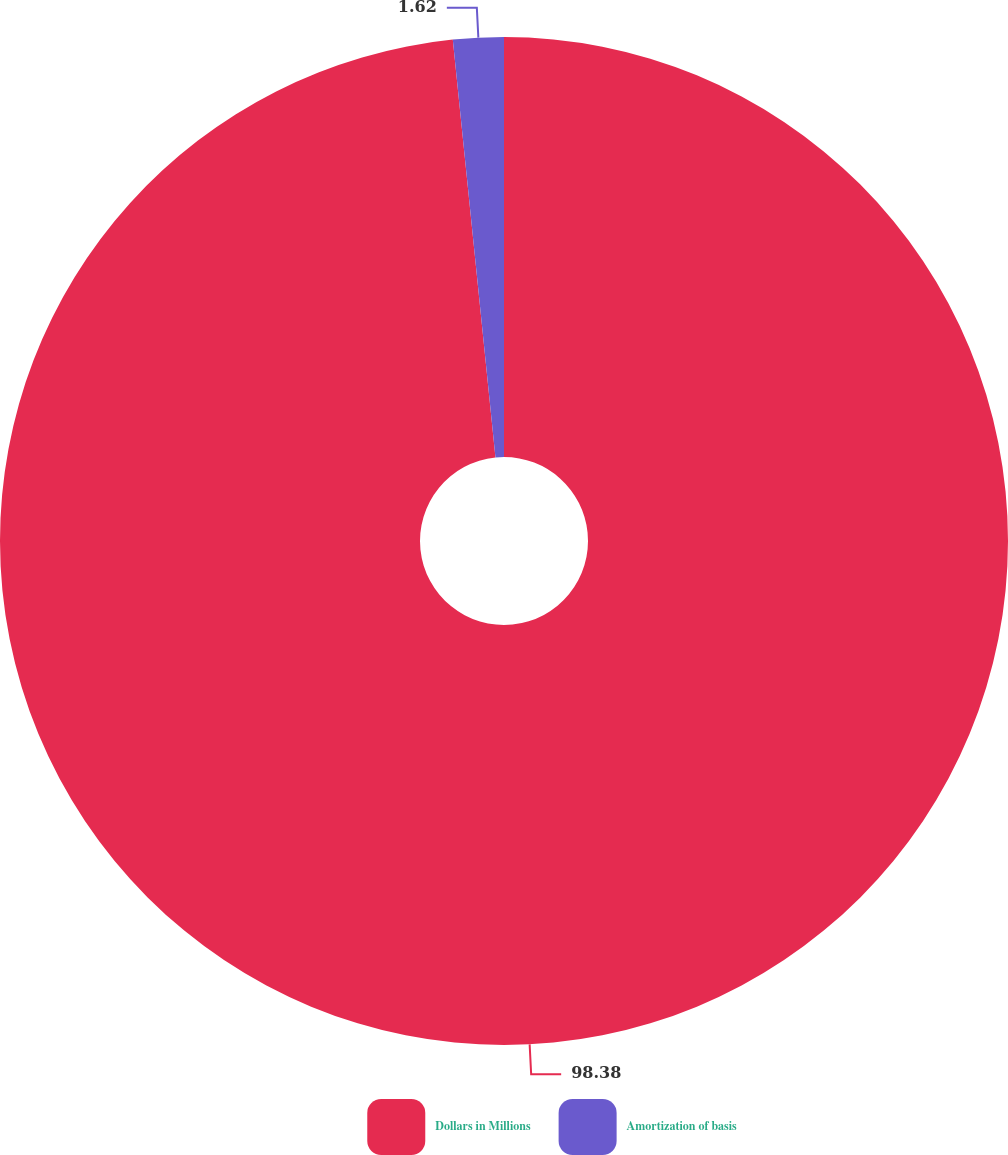Convert chart. <chart><loc_0><loc_0><loc_500><loc_500><pie_chart><fcel>Dollars in Millions<fcel>Amortization of basis<nl><fcel>98.38%<fcel>1.62%<nl></chart> 